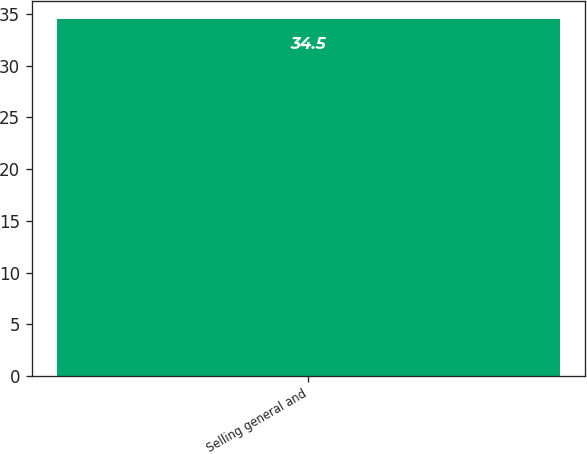Convert chart. <chart><loc_0><loc_0><loc_500><loc_500><bar_chart><fcel>Selling general and<nl><fcel>34.5<nl></chart> 